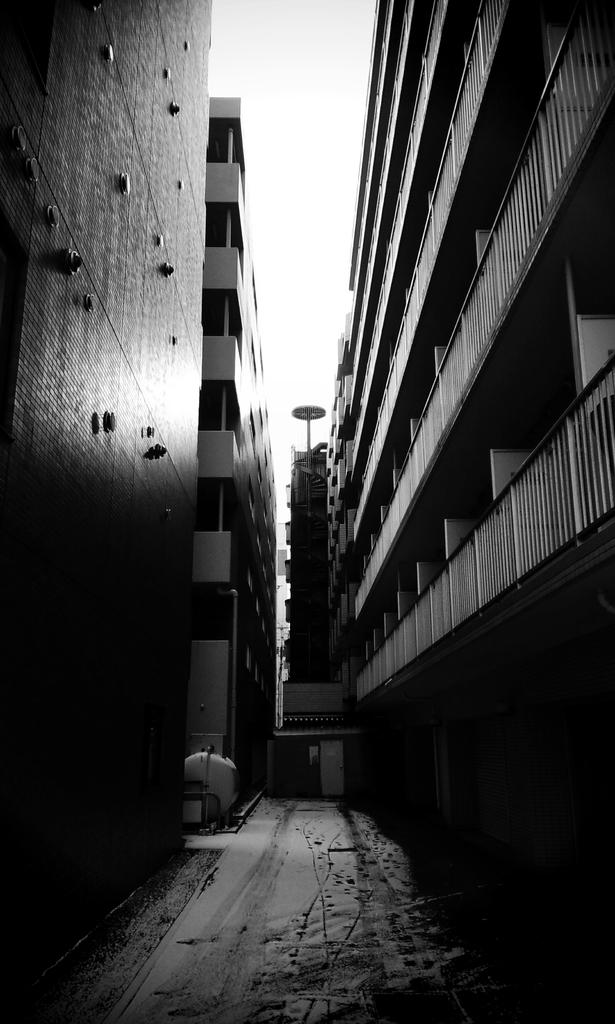What is the color scheme of the image? The image is black and white. What type of structures can be seen in the image? There are buildings in the image. What architectural feature is present in the image? There are railings in the image. What is visible at the top of the image? The sky is visible in the image. How much sugar is present in the image? There is no sugar present in the image, as it features buildings and railings. What type of wrench can be seen being used in the image? There is no wrench present in the image. 